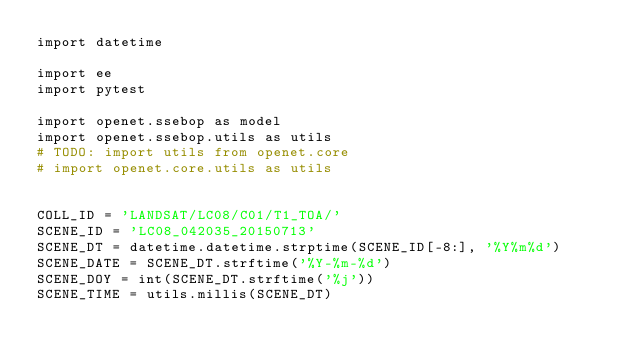<code> <loc_0><loc_0><loc_500><loc_500><_Python_>import datetime

import ee
import pytest

import openet.ssebop as model
import openet.ssebop.utils as utils
# TODO: import utils from openet.core
# import openet.core.utils as utils


COLL_ID = 'LANDSAT/LC08/C01/T1_TOA/'
SCENE_ID = 'LC08_042035_20150713'
SCENE_DT = datetime.datetime.strptime(SCENE_ID[-8:], '%Y%m%d')
SCENE_DATE = SCENE_DT.strftime('%Y-%m-%d')
SCENE_DOY = int(SCENE_DT.strftime('%j'))
SCENE_TIME = utils.millis(SCENE_DT)</code> 